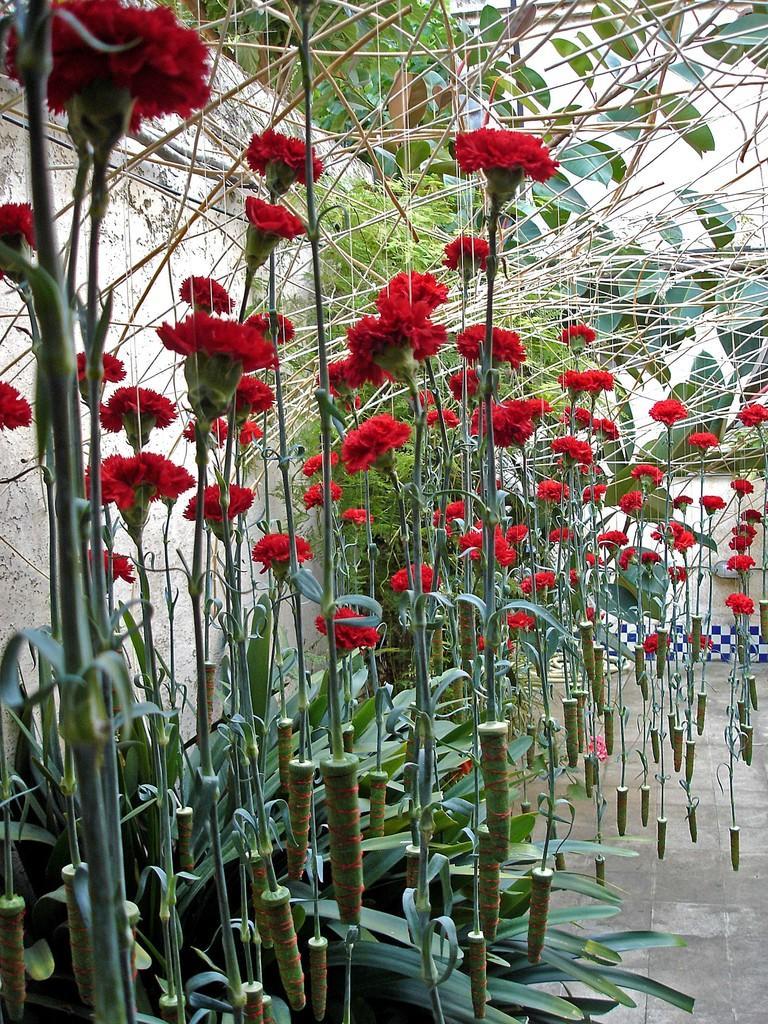In one or two sentences, can you explain what this image depicts? In this we can see the plants with red color flowers. This is the wall and this is the floor. 